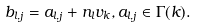<formula> <loc_0><loc_0><loc_500><loc_500>b _ { l , j } = a _ { l , j } + n _ { l } v _ { k } , a _ { l , j } \in \Gamma ( k ) .</formula> 